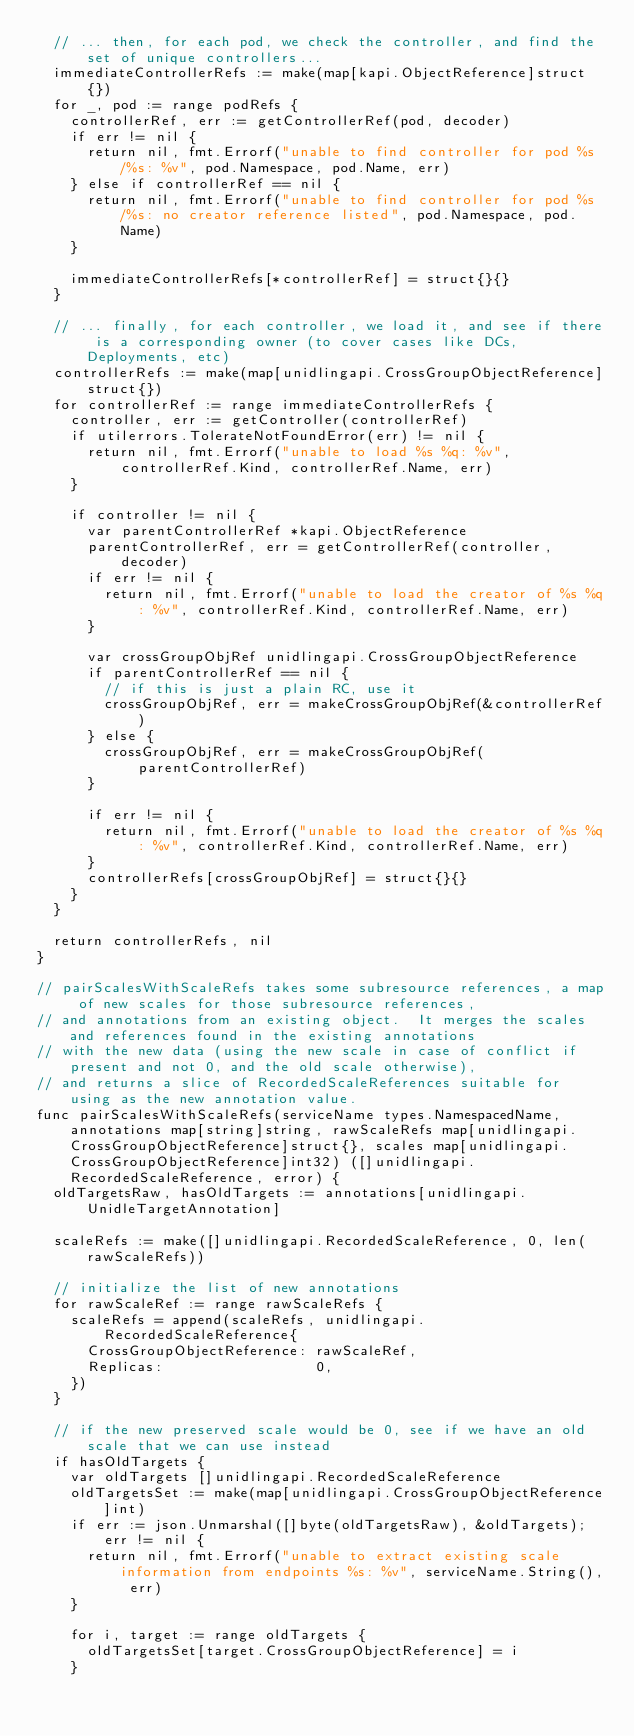<code> <loc_0><loc_0><loc_500><loc_500><_Go_>	// ... then, for each pod, we check the controller, and find the set of unique controllers...
	immediateControllerRefs := make(map[kapi.ObjectReference]struct{})
	for _, pod := range podRefs {
		controllerRef, err := getControllerRef(pod, decoder)
		if err != nil {
			return nil, fmt.Errorf("unable to find controller for pod %s/%s: %v", pod.Namespace, pod.Name, err)
		} else if controllerRef == nil {
			return nil, fmt.Errorf("unable to find controller for pod %s/%s: no creator reference listed", pod.Namespace, pod.Name)
		}

		immediateControllerRefs[*controllerRef] = struct{}{}
	}

	// ... finally, for each controller, we load it, and see if there is a corresponding owner (to cover cases like DCs, Deployments, etc)
	controllerRefs := make(map[unidlingapi.CrossGroupObjectReference]struct{})
	for controllerRef := range immediateControllerRefs {
		controller, err := getController(controllerRef)
		if utilerrors.TolerateNotFoundError(err) != nil {
			return nil, fmt.Errorf("unable to load %s %q: %v", controllerRef.Kind, controllerRef.Name, err)
		}

		if controller != nil {
			var parentControllerRef *kapi.ObjectReference
			parentControllerRef, err = getControllerRef(controller, decoder)
			if err != nil {
				return nil, fmt.Errorf("unable to load the creator of %s %q: %v", controllerRef.Kind, controllerRef.Name, err)
			}

			var crossGroupObjRef unidlingapi.CrossGroupObjectReference
			if parentControllerRef == nil {
				// if this is just a plain RC, use it
				crossGroupObjRef, err = makeCrossGroupObjRef(&controllerRef)
			} else {
				crossGroupObjRef, err = makeCrossGroupObjRef(parentControllerRef)
			}

			if err != nil {
				return nil, fmt.Errorf("unable to load the creator of %s %q: %v", controllerRef.Kind, controllerRef.Name, err)
			}
			controllerRefs[crossGroupObjRef] = struct{}{}
		}
	}

	return controllerRefs, nil
}

// pairScalesWithScaleRefs takes some subresource references, a map of new scales for those subresource references,
// and annotations from an existing object.  It merges the scales and references found in the existing annotations
// with the new data (using the new scale in case of conflict if present and not 0, and the old scale otherwise),
// and returns a slice of RecordedScaleReferences suitable for using as the new annotation value.
func pairScalesWithScaleRefs(serviceName types.NamespacedName, annotations map[string]string, rawScaleRefs map[unidlingapi.CrossGroupObjectReference]struct{}, scales map[unidlingapi.CrossGroupObjectReference]int32) ([]unidlingapi.RecordedScaleReference, error) {
	oldTargetsRaw, hasOldTargets := annotations[unidlingapi.UnidleTargetAnnotation]

	scaleRefs := make([]unidlingapi.RecordedScaleReference, 0, len(rawScaleRefs))

	// initialize the list of new annotations
	for rawScaleRef := range rawScaleRefs {
		scaleRefs = append(scaleRefs, unidlingapi.RecordedScaleReference{
			CrossGroupObjectReference: rawScaleRef,
			Replicas:                  0,
		})
	}

	// if the new preserved scale would be 0, see if we have an old scale that we can use instead
	if hasOldTargets {
		var oldTargets []unidlingapi.RecordedScaleReference
		oldTargetsSet := make(map[unidlingapi.CrossGroupObjectReference]int)
		if err := json.Unmarshal([]byte(oldTargetsRaw), &oldTargets); err != nil {
			return nil, fmt.Errorf("unable to extract existing scale information from endpoints %s: %v", serviceName.String(), err)
		}

		for i, target := range oldTargets {
			oldTargetsSet[target.CrossGroupObjectReference] = i
		}
</code> 